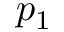Convert formula to latex. <formula><loc_0><loc_0><loc_500><loc_500>p _ { 1 }</formula> 